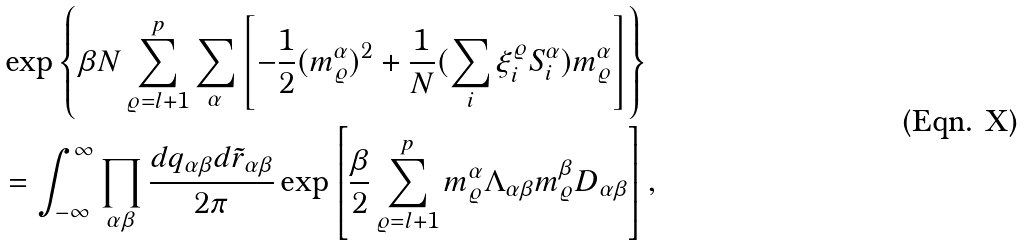<formula> <loc_0><loc_0><loc_500><loc_500>& \exp \left \{ \beta N \sum _ { \varrho = l + 1 } ^ { p } \sum _ { \alpha } \left [ - \frac { 1 } { 2 } ( m _ { \varrho } ^ { \alpha } ) ^ { 2 } + \frac { 1 } { N } ( \sum _ { i } \xi _ { i } ^ { \varrho } S _ { i } ^ { \alpha } ) m _ { \varrho } ^ { \alpha } \right ] \right \} \\ & = \int _ { - \infty } ^ { \infty } \prod _ { \alpha \beta } \frac { d q _ { \alpha \beta } d \tilde { r } _ { \alpha \beta } } { 2 \pi } \exp \left [ \frac { \beta } { 2 } \sum _ { \varrho = l + 1 } ^ { p } m _ { \varrho } ^ { \alpha } \Lambda _ { \alpha \beta } m _ { \varrho } ^ { \beta } D _ { \alpha \beta } \right ] ,</formula> 